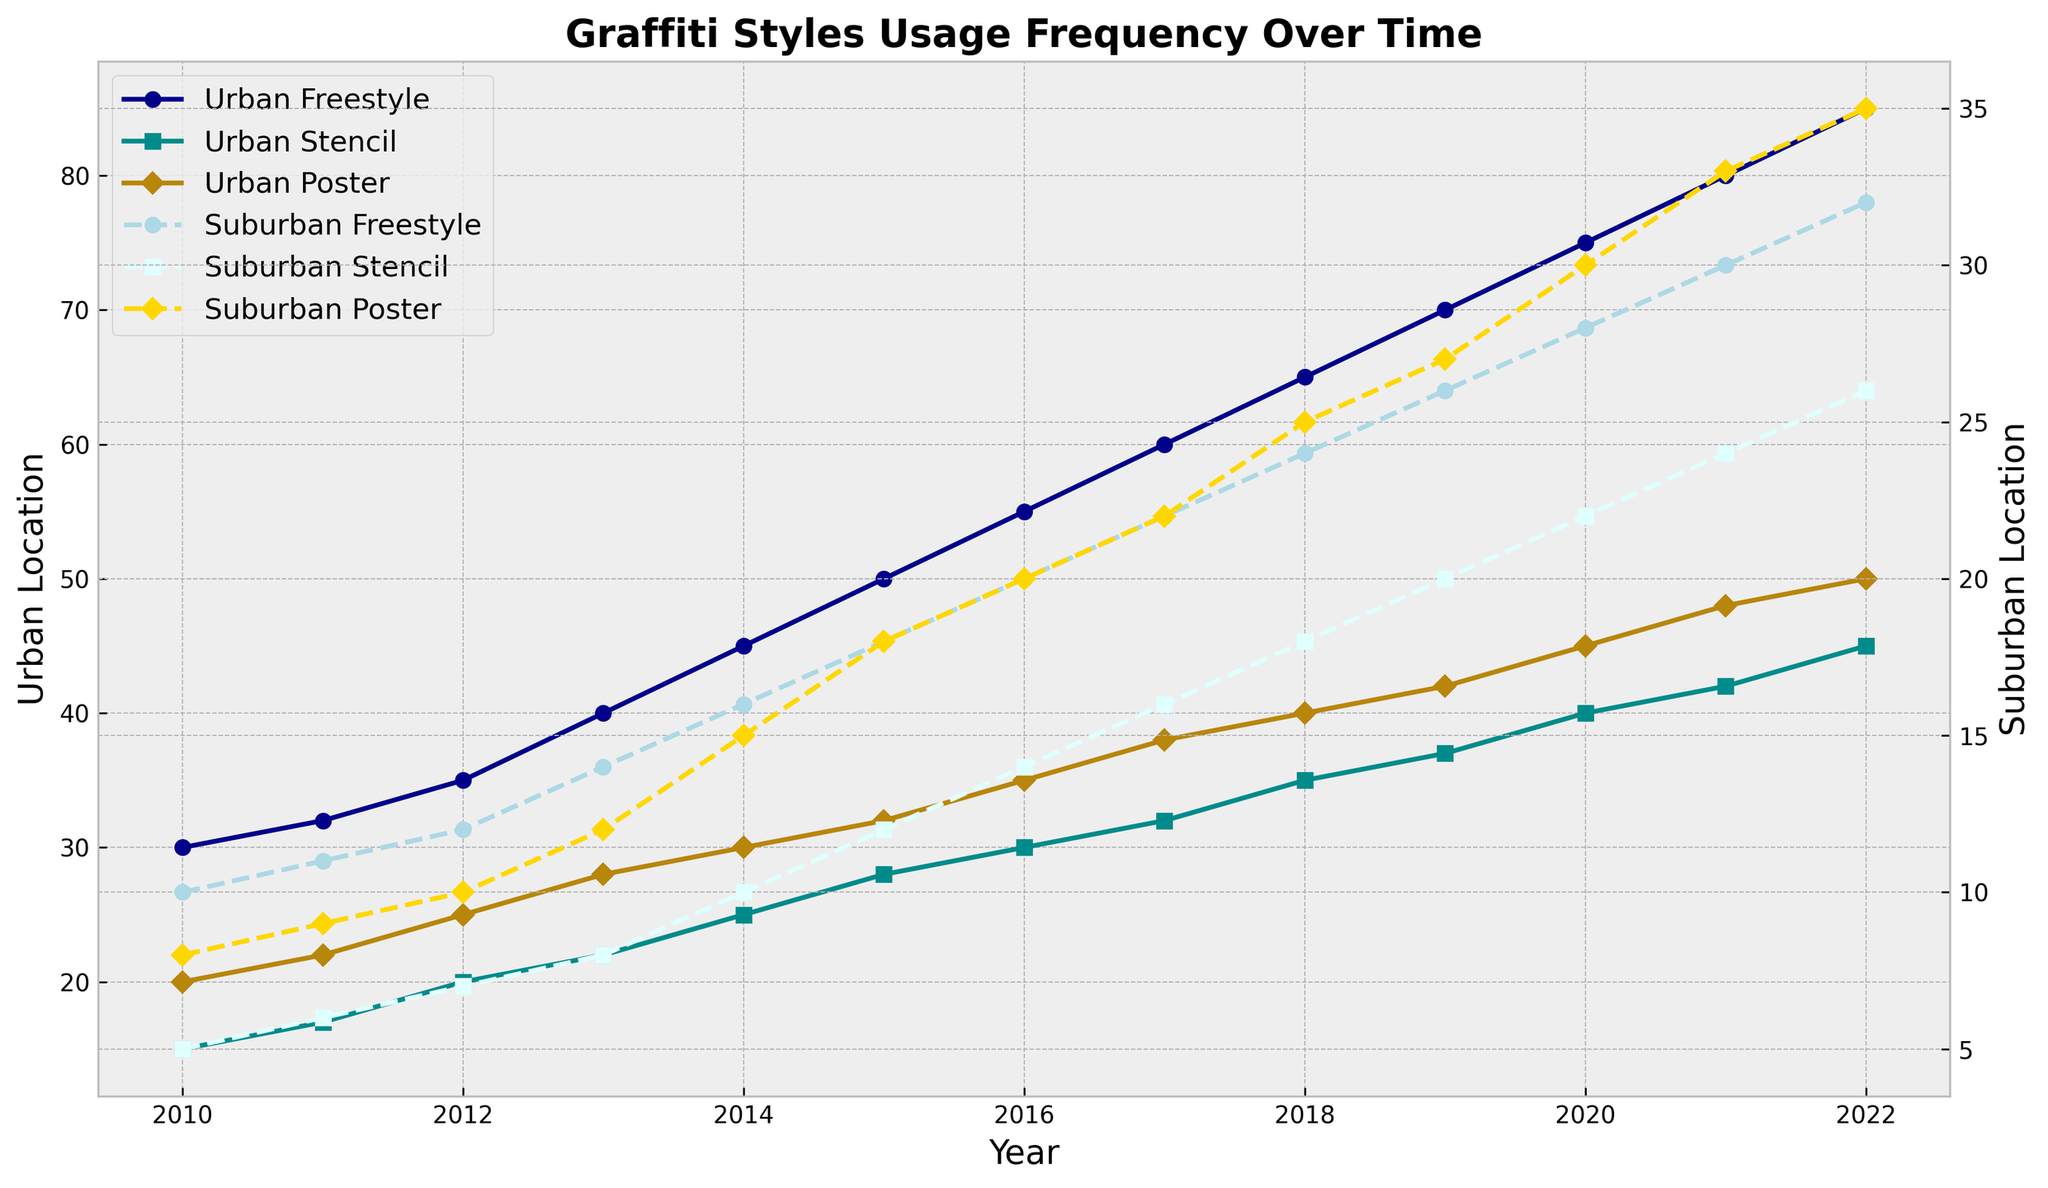What is the general trend in the usage of Urban Freestyle graffiti style from 2010 to 2022? The plot shows a steady increase in the frequency of Urban Freestyle graffiti style from 30 in 2010 to 85 in 2022.
Answer: Steady increase How does the frequency of Suburban Poster graffiti in 2022 compare to Urban Poster graffiti in the same year? In 2022, Suburban Poster graffiti has a frequency of 35, while Urban Poster graffiti has a frequency of 50.
Answer: Suburban: 35, Urban: 50 Which style of graffiti in urban locations has the highest increase in usage from 2010 to 2022? Urban Freestyle graffiti increased from 30 in 2010 to 85 in 2022, which is an increase of 55, the highest among the styles.
Answer: Urban Freestyle Compare the frequency of Urban and Suburban Freestyle graffiti in 2020. Which is higher and by how much? In 2020, Urban Freestyle graffiti has a frequency of 75, whereas Suburban Freestyle graffiti has a frequency of 28. Urban is higher by 47.
Answer: Urban by 47 Which graffiti style showed the smallest increase in usage in suburban locations from 2010 to 2022? Suburban Stencil graffiti increased from 5 in 2010 to 26 in 2022, an increase of 21, smaller than the increases seen in Freestyle and Poster.
Answer: Suburban Stencil What is the average frequency of Urban Stencil graffiti over the years 2016 to 2022? The frequencies from 2016 to 2022 are 30, 32, 35, 37, 40, 42, 45. The average is (30+32+35+37+40+42+45)/7 ≈ 37.29.
Answer: ≈ 37.29 In which year did Urban Poster graffiti first surpass a frequency of 40? In 2018, Urban Poster graffiti has a frequency of 40. In 2019, it surpasses it with a frequency of 42.
Answer: 2019 What are the total frequencies of all graffiti styles in urban locations in 2015? Urban Freestyle: 50, Urban Stencil: 28, Urban Poster: 32. The total is 50+28+32 = 110.
Answer: 110 Considering the entire period from 2010 to 2022, which suburban graffiti style increased its frequency the most? Suburban Poster increased from 8 in 2010 to 35 in 2022, an increase of 27, which is the highest among the suburban styles.
Answer: Suburban Poster Which year saw the highest frequency of Suburban Freestyle graffiti? The highest frequency of Suburban Freestyle graffiti is in 2022, with a frequency of 32.
Answer: 2022 What is the difference in frequency between Urban and Suburban Stencil graffiti in 2014? In 2014, the frequency of Urban Stencil is 25 and Suburban Stencil is 10. The difference is 25 - 10 = 15.
Answer: 15 